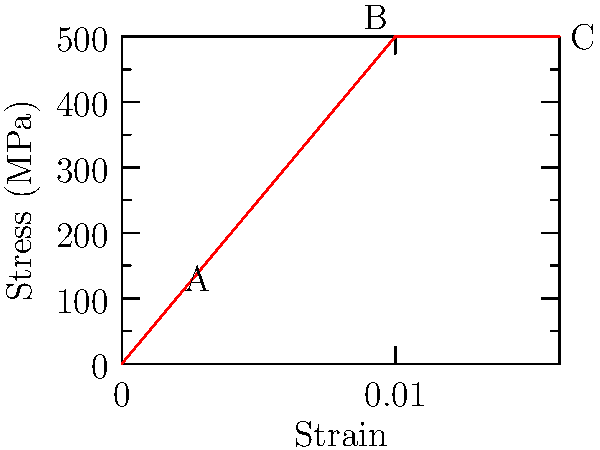At your startup's latest themed party, "Material Science Madness," you're discussing stress-strain curves with a colleague. Given the stress-strain curve for a new party decoration material shown above, determine the material's modulus of elasticity in GPa. Assume the linear region extends from point A to point B. To find the modulus of elasticity (Young's modulus), we need to calculate the slope of the linear region in the stress-strain curve. Let's follow these steps:

1. Identify the coordinates of points A and B:
   Point A: (0.002, 100 MPa)
   Point B: (0.01, 500 MPa)

2. Calculate the change in stress (Δσ):
   Δσ = 500 MPa - 100 MPa = 400 MPa

3. Calculate the change in strain (Δε):
   Δε = 0.01 - 0.002 = 0.008

4. Apply the formula for Young's modulus (E):
   $E = \frac{\Delta\sigma}{\Delta\epsilon}$

5. Substitute the values:
   $E = \frac{400 \text{ MPa}}{0.008} = 50,000 \text{ MPa}$

6. Convert MPa to GPa:
   $E = 50,000 \text{ MPa} \times \frac{1 \text{ GPa}}{1000 \text{ MPa}} = 50 \text{ GPa}$

Therefore, the modulus of elasticity of the material is 50 GPa.
Answer: 50 GPa 